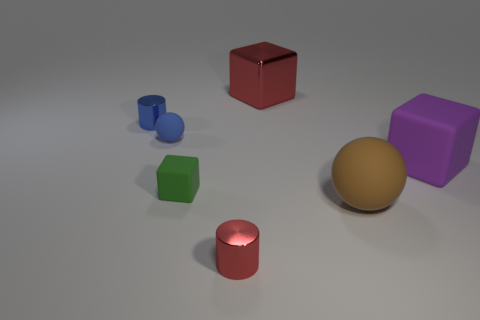Add 1 big brown shiny blocks. How many objects exist? 8 Subtract all spheres. How many objects are left? 5 Subtract 0 cyan blocks. How many objects are left? 7 Subtract all big gray blocks. Subtract all tiny spheres. How many objects are left? 6 Add 4 large brown matte things. How many large brown matte things are left? 5 Add 7 large red cylinders. How many large red cylinders exist? 7 